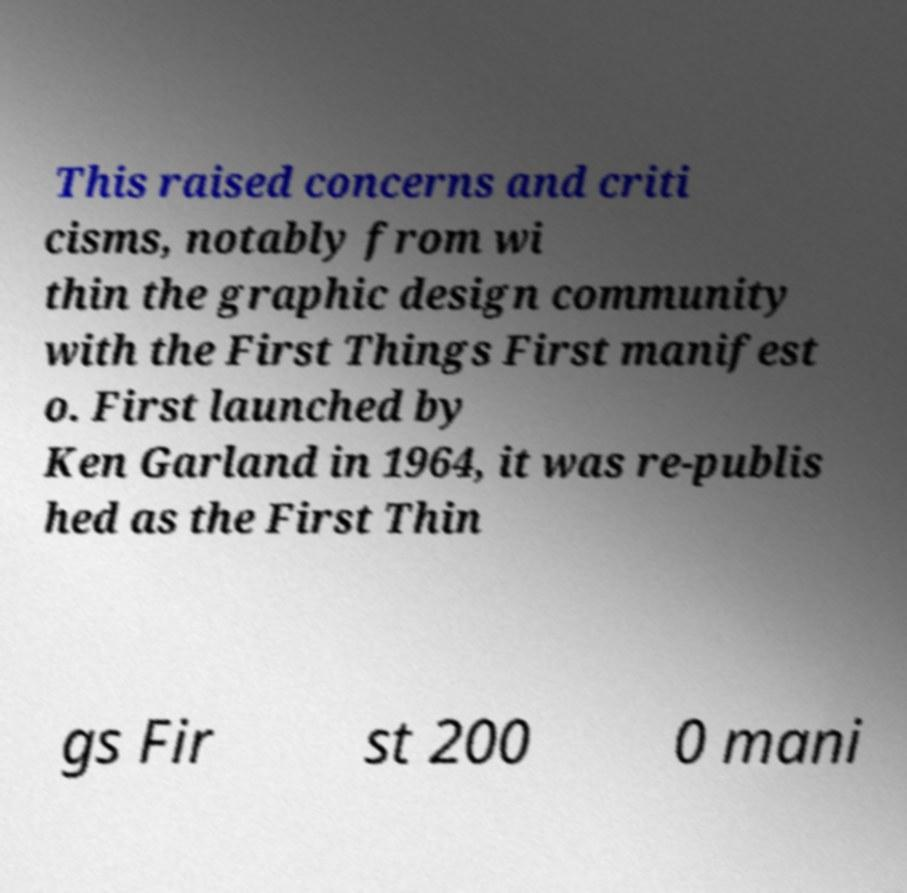Could you extract and type out the text from this image? This raised concerns and criti cisms, notably from wi thin the graphic design community with the First Things First manifest o. First launched by Ken Garland in 1964, it was re-publis hed as the First Thin gs Fir st 200 0 mani 